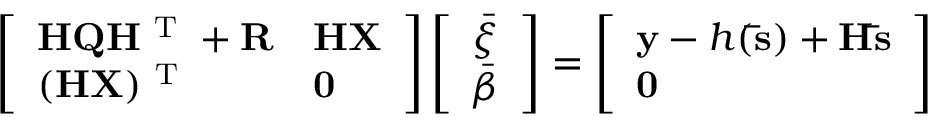Convert formula to latex. <formula><loc_0><loc_0><loc_500><loc_500>\left [ \begin{array} { l l } { H Q H ^ { T } + R } & { H X } \\ { ( H X ) ^ { T } } & { 0 } \end{array} \right ] \left [ \begin{array} { l } { \bar { \xi } } \\ { \bar { \beta } } \end{array} \right ] = \left [ \begin{array} { l } { y - h ( \bar { s } ) + H \bar { s } } \\ { 0 } \end{array} \right ]</formula> 